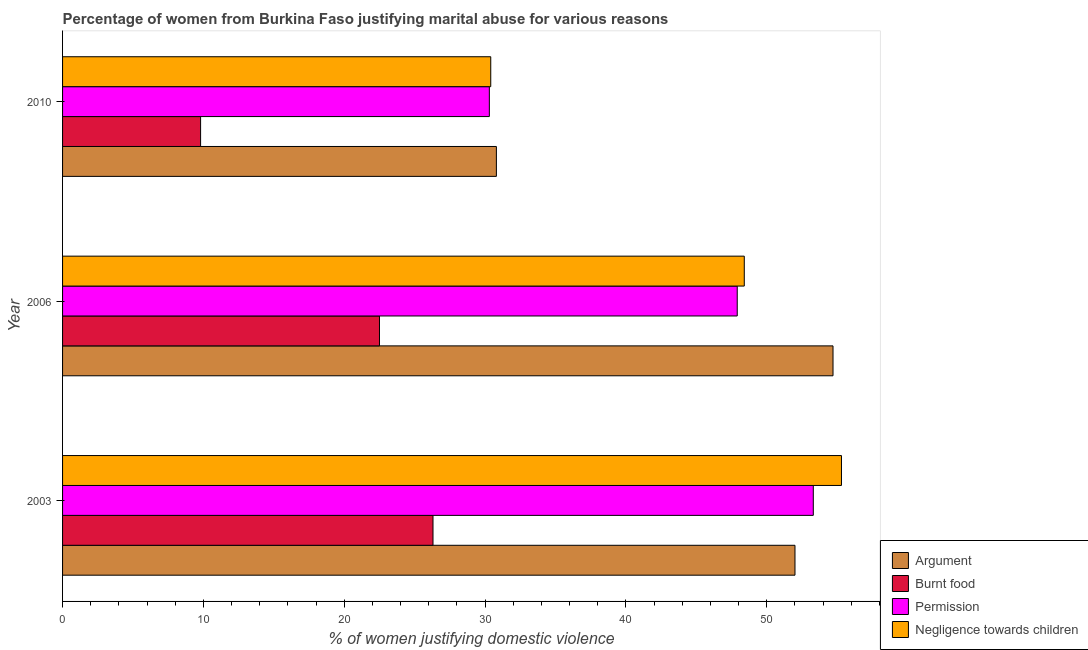How many different coloured bars are there?
Provide a short and direct response. 4. How many groups of bars are there?
Offer a terse response. 3. Are the number of bars per tick equal to the number of legend labels?
Ensure brevity in your answer.  Yes. Are the number of bars on each tick of the Y-axis equal?
Your response must be concise. Yes. How many bars are there on the 2nd tick from the bottom?
Your answer should be compact. 4. What is the label of the 1st group of bars from the top?
Offer a terse response. 2010. What is the percentage of women justifying abuse for burning food in 2006?
Ensure brevity in your answer.  22.5. Across all years, what is the maximum percentage of women justifying abuse for going without permission?
Your response must be concise. 53.3. Across all years, what is the minimum percentage of women justifying abuse for going without permission?
Keep it short and to the point. 30.3. What is the total percentage of women justifying abuse for going without permission in the graph?
Offer a very short reply. 131.5. What is the difference between the percentage of women justifying abuse for showing negligence towards children in 2003 and that in 2006?
Give a very brief answer. 6.9. What is the difference between the percentage of women justifying abuse in the case of an argument in 2003 and the percentage of women justifying abuse for showing negligence towards children in 2006?
Your answer should be very brief. 3.6. What is the average percentage of women justifying abuse for showing negligence towards children per year?
Your answer should be very brief. 44.7. In how many years, is the percentage of women justifying abuse in the case of an argument greater than 28 %?
Offer a terse response. 3. What is the ratio of the percentage of women justifying abuse for showing negligence towards children in 2003 to that in 2010?
Offer a very short reply. 1.82. Is the difference between the percentage of women justifying abuse in the case of an argument in 2003 and 2006 greater than the difference between the percentage of women justifying abuse for showing negligence towards children in 2003 and 2006?
Your response must be concise. No. What is the difference between the highest and the second highest percentage of women justifying abuse for going without permission?
Ensure brevity in your answer.  5.4. Is it the case that in every year, the sum of the percentage of women justifying abuse in the case of an argument and percentage of women justifying abuse for burning food is greater than the sum of percentage of women justifying abuse for showing negligence towards children and percentage of women justifying abuse for going without permission?
Make the answer very short. No. What does the 3rd bar from the top in 2003 represents?
Provide a succinct answer. Burnt food. What does the 4th bar from the bottom in 2006 represents?
Ensure brevity in your answer.  Negligence towards children. Is it the case that in every year, the sum of the percentage of women justifying abuse in the case of an argument and percentage of women justifying abuse for burning food is greater than the percentage of women justifying abuse for going without permission?
Offer a very short reply. Yes. How many bars are there?
Provide a short and direct response. 12. Are all the bars in the graph horizontal?
Provide a succinct answer. Yes. Are the values on the major ticks of X-axis written in scientific E-notation?
Keep it short and to the point. No. How are the legend labels stacked?
Give a very brief answer. Vertical. What is the title of the graph?
Ensure brevity in your answer.  Percentage of women from Burkina Faso justifying marital abuse for various reasons. Does "Other expenses" appear as one of the legend labels in the graph?
Ensure brevity in your answer.  No. What is the label or title of the X-axis?
Make the answer very short. % of women justifying domestic violence. What is the % of women justifying domestic violence in Argument in 2003?
Your answer should be very brief. 52. What is the % of women justifying domestic violence of Burnt food in 2003?
Provide a short and direct response. 26.3. What is the % of women justifying domestic violence in Permission in 2003?
Give a very brief answer. 53.3. What is the % of women justifying domestic violence in Negligence towards children in 2003?
Keep it short and to the point. 55.3. What is the % of women justifying domestic violence of Argument in 2006?
Keep it short and to the point. 54.7. What is the % of women justifying domestic violence of Burnt food in 2006?
Provide a succinct answer. 22.5. What is the % of women justifying domestic violence in Permission in 2006?
Offer a terse response. 47.9. What is the % of women justifying domestic violence in Negligence towards children in 2006?
Make the answer very short. 48.4. What is the % of women justifying domestic violence in Argument in 2010?
Offer a terse response. 30.8. What is the % of women justifying domestic violence in Burnt food in 2010?
Keep it short and to the point. 9.8. What is the % of women justifying domestic violence in Permission in 2010?
Offer a terse response. 30.3. What is the % of women justifying domestic violence of Negligence towards children in 2010?
Make the answer very short. 30.4. Across all years, what is the maximum % of women justifying domestic violence in Argument?
Give a very brief answer. 54.7. Across all years, what is the maximum % of women justifying domestic violence in Burnt food?
Keep it short and to the point. 26.3. Across all years, what is the maximum % of women justifying domestic violence in Permission?
Give a very brief answer. 53.3. Across all years, what is the maximum % of women justifying domestic violence of Negligence towards children?
Your answer should be very brief. 55.3. Across all years, what is the minimum % of women justifying domestic violence of Argument?
Your answer should be very brief. 30.8. Across all years, what is the minimum % of women justifying domestic violence in Burnt food?
Your answer should be very brief. 9.8. Across all years, what is the minimum % of women justifying domestic violence of Permission?
Offer a very short reply. 30.3. Across all years, what is the minimum % of women justifying domestic violence in Negligence towards children?
Your answer should be very brief. 30.4. What is the total % of women justifying domestic violence of Argument in the graph?
Keep it short and to the point. 137.5. What is the total % of women justifying domestic violence of Burnt food in the graph?
Give a very brief answer. 58.6. What is the total % of women justifying domestic violence of Permission in the graph?
Ensure brevity in your answer.  131.5. What is the total % of women justifying domestic violence of Negligence towards children in the graph?
Give a very brief answer. 134.1. What is the difference between the % of women justifying domestic violence in Argument in 2003 and that in 2006?
Your answer should be very brief. -2.7. What is the difference between the % of women justifying domestic violence of Burnt food in 2003 and that in 2006?
Make the answer very short. 3.8. What is the difference between the % of women justifying domestic violence in Argument in 2003 and that in 2010?
Make the answer very short. 21.2. What is the difference between the % of women justifying domestic violence of Negligence towards children in 2003 and that in 2010?
Your response must be concise. 24.9. What is the difference between the % of women justifying domestic violence in Argument in 2006 and that in 2010?
Offer a very short reply. 23.9. What is the difference between the % of women justifying domestic violence in Burnt food in 2006 and that in 2010?
Give a very brief answer. 12.7. What is the difference between the % of women justifying domestic violence in Permission in 2006 and that in 2010?
Offer a terse response. 17.6. What is the difference between the % of women justifying domestic violence in Argument in 2003 and the % of women justifying domestic violence in Burnt food in 2006?
Provide a short and direct response. 29.5. What is the difference between the % of women justifying domestic violence in Argument in 2003 and the % of women justifying domestic violence in Permission in 2006?
Your answer should be compact. 4.1. What is the difference between the % of women justifying domestic violence of Argument in 2003 and the % of women justifying domestic violence of Negligence towards children in 2006?
Offer a very short reply. 3.6. What is the difference between the % of women justifying domestic violence in Burnt food in 2003 and the % of women justifying domestic violence in Permission in 2006?
Your response must be concise. -21.6. What is the difference between the % of women justifying domestic violence of Burnt food in 2003 and the % of women justifying domestic violence of Negligence towards children in 2006?
Offer a terse response. -22.1. What is the difference between the % of women justifying domestic violence in Argument in 2003 and the % of women justifying domestic violence in Burnt food in 2010?
Offer a terse response. 42.2. What is the difference between the % of women justifying domestic violence in Argument in 2003 and the % of women justifying domestic violence in Permission in 2010?
Your answer should be very brief. 21.7. What is the difference between the % of women justifying domestic violence in Argument in 2003 and the % of women justifying domestic violence in Negligence towards children in 2010?
Make the answer very short. 21.6. What is the difference between the % of women justifying domestic violence of Burnt food in 2003 and the % of women justifying domestic violence of Negligence towards children in 2010?
Offer a terse response. -4.1. What is the difference between the % of women justifying domestic violence in Permission in 2003 and the % of women justifying domestic violence in Negligence towards children in 2010?
Give a very brief answer. 22.9. What is the difference between the % of women justifying domestic violence of Argument in 2006 and the % of women justifying domestic violence of Burnt food in 2010?
Your answer should be compact. 44.9. What is the difference between the % of women justifying domestic violence of Argument in 2006 and the % of women justifying domestic violence of Permission in 2010?
Make the answer very short. 24.4. What is the difference between the % of women justifying domestic violence in Argument in 2006 and the % of women justifying domestic violence in Negligence towards children in 2010?
Your answer should be very brief. 24.3. What is the difference between the % of women justifying domestic violence of Burnt food in 2006 and the % of women justifying domestic violence of Permission in 2010?
Your answer should be compact. -7.8. What is the difference between the % of women justifying domestic violence in Burnt food in 2006 and the % of women justifying domestic violence in Negligence towards children in 2010?
Your answer should be compact. -7.9. What is the difference between the % of women justifying domestic violence of Permission in 2006 and the % of women justifying domestic violence of Negligence towards children in 2010?
Your answer should be very brief. 17.5. What is the average % of women justifying domestic violence of Argument per year?
Ensure brevity in your answer.  45.83. What is the average % of women justifying domestic violence of Burnt food per year?
Make the answer very short. 19.53. What is the average % of women justifying domestic violence in Permission per year?
Your response must be concise. 43.83. What is the average % of women justifying domestic violence in Negligence towards children per year?
Your answer should be very brief. 44.7. In the year 2003, what is the difference between the % of women justifying domestic violence in Argument and % of women justifying domestic violence in Burnt food?
Your response must be concise. 25.7. In the year 2003, what is the difference between the % of women justifying domestic violence in Argument and % of women justifying domestic violence in Permission?
Offer a terse response. -1.3. In the year 2003, what is the difference between the % of women justifying domestic violence in Argument and % of women justifying domestic violence in Negligence towards children?
Your answer should be compact. -3.3. In the year 2006, what is the difference between the % of women justifying domestic violence of Argument and % of women justifying domestic violence of Burnt food?
Offer a very short reply. 32.2. In the year 2006, what is the difference between the % of women justifying domestic violence in Argument and % of women justifying domestic violence in Negligence towards children?
Provide a succinct answer. 6.3. In the year 2006, what is the difference between the % of women justifying domestic violence of Burnt food and % of women justifying domestic violence of Permission?
Keep it short and to the point. -25.4. In the year 2006, what is the difference between the % of women justifying domestic violence of Burnt food and % of women justifying domestic violence of Negligence towards children?
Ensure brevity in your answer.  -25.9. In the year 2010, what is the difference between the % of women justifying domestic violence in Argument and % of women justifying domestic violence in Burnt food?
Offer a terse response. 21. In the year 2010, what is the difference between the % of women justifying domestic violence in Burnt food and % of women justifying domestic violence in Permission?
Keep it short and to the point. -20.5. In the year 2010, what is the difference between the % of women justifying domestic violence in Burnt food and % of women justifying domestic violence in Negligence towards children?
Ensure brevity in your answer.  -20.6. What is the ratio of the % of women justifying domestic violence in Argument in 2003 to that in 2006?
Your answer should be very brief. 0.95. What is the ratio of the % of women justifying domestic violence in Burnt food in 2003 to that in 2006?
Offer a terse response. 1.17. What is the ratio of the % of women justifying domestic violence of Permission in 2003 to that in 2006?
Provide a short and direct response. 1.11. What is the ratio of the % of women justifying domestic violence in Negligence towards children in 2003 to that in 2006?
Give a very brief answer. 1.14. What is the ratio of the % of women justifying domestic violence of Argument in 2003 to that in 2010?
Give a very brief answer. 1.69. What is the ratio of the % of women justifying domestic violence in Burnt food in 2003 to that in 2010?
Keep it short and to the point. 2.68. What is the ratio of the % of women justifying domestic violence in Permission in 2003 to that in 2010?
Make the answer very short. 1.76. What is the ratio of the % of women justifying domestic violence in Negligence towards children in 2003 to that in 2010?
Keep it short and to the point. 1.82. What is the ratio of the % of women justifying domestic violence in Argument in 2006 to that in 2010?
Ensure brevity in your answer.  1.78. What is the ratio of the % of women justifying domestic violence in Burnt food in 2006 to that in 2010?
Give a very brief answer. 2.3. What is the ratio of the % of women justifying domestic violence of Permission in 2006 to that in 2010?
Your answer should be compact. 1.58. What is the ratio of the % of women justifying domestic violence in Negligence towards children in 2006 to that in 2010?
Your answer should be compact. 1.59. What is the difference between the highest and the second highest % of women justifying domestic violence in Argument?
Ensure brevity in your answer.  2.7. What is the difference between the highest and the second highest % of women justifying domestic violence of Permission?
Your response must be concise. 5.4. What is the difference between the highest and the second highest % of women justifying domestic violence of Negligence towards children?
Give a very brief answer. 6.9. What is the difference between the highest and the lowest % of women justifying domestic violence in Argument?
Make the answer very short. 23.9. What is the difference between the highest and the lowest % of women justifying domestic violence of Permission?
Offer a terse response. 23. What is the difference between the highest and the lowest % of women justifying domestic violence of Negligence towards children?
Offer a very short reply. 24.9. 